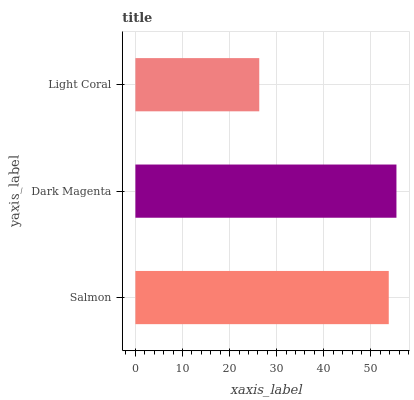Is Light Coral the minimum?
Answer yes or no. Yes. Is Dark Magenta the maximum?
Answer yes or no. Yes. Is Dark Magenta the minimum?
Answer yes or no. No. Is Light Coral the maximum?
Answer yes or no. No. Is Dark Magenta greater than Light Coral?
Answer yes or no. Yes. Is Light Coral less than Dark Magenta?
Answer yes or no. Yes. Is Light Coral greater than Dark Magenta?
Answer yes or no. No. Is Dark Magenta less than Light Coral?
Answer yes or no. No. Is Salmon the high median?
Answer yes or no. Yes. Is Salmon the low median?
Answer yes or no. Yes. Is Light Coral the high median?
Answer yes or no. No. Is Light Coral the low median?
Answer yes or no. No. 